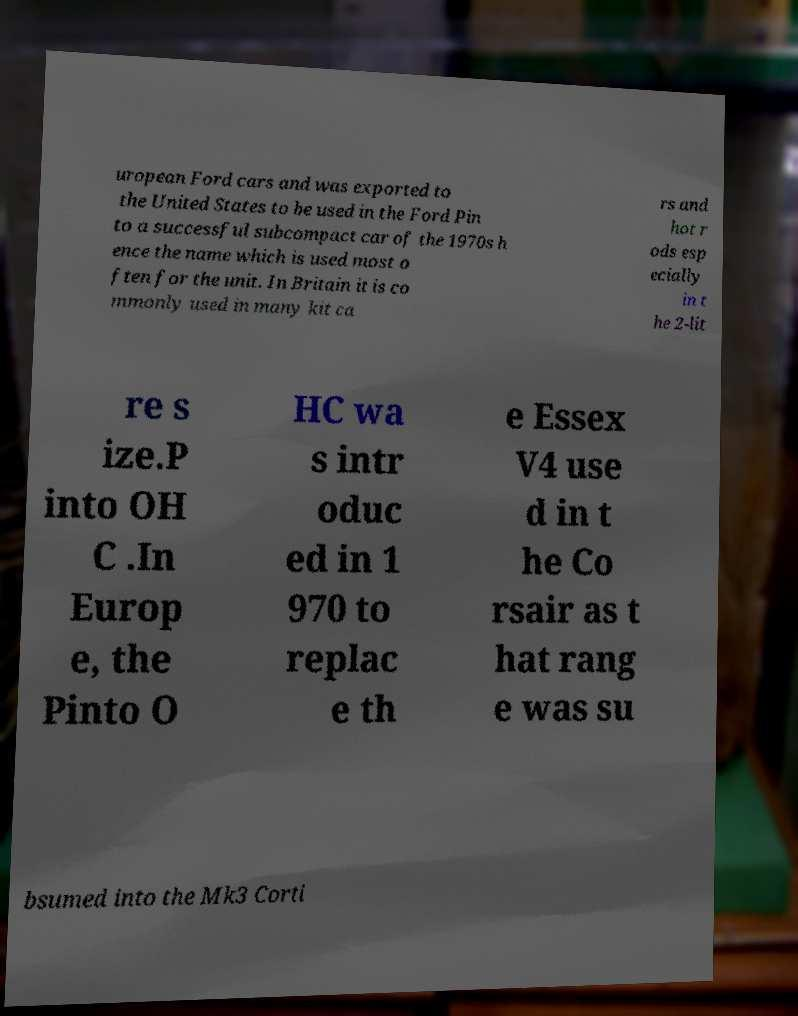Please identify and transcribe the text found in this image. uropean Ford cars and was exported to the United States to be used in the Ford Pin to a successful subcompact car of the 1970s h ence the name which is used most o ften for the unit. In Britain it is co mmonly used in many kit ca rs and hot r ods esp ecially in t he 2-lit re s ize.P into OH C .In Europ e, the Pinto O HC wa s intr oduc ed in 1 970 to replac e th e Essex V4 use d in t he Co rsair as t hat rang e was su bsumed into the Mk3 Corti 